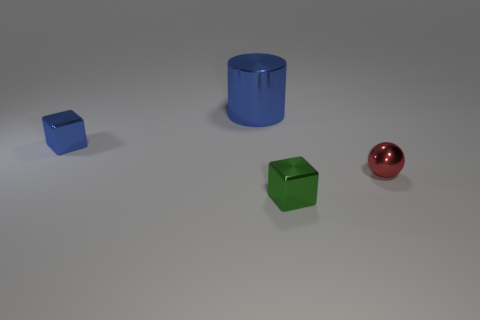Imagine this is a scene from a story. What narrative could you construct about these objects? In a narrative context, these objects could symbolize characters or elements within a tale of difference and unity. The small blue cube could represent the young, curious individual starting a journey. The green cube could depict a wise mentor with deeper layers, akin to the object's more complex shape. The red sphere might symbolize a guiding spirit or a beacon of wisdom, slightly apart but deeply connected to the rest. The cylindrical object, with its open top, could embody an unknown destination or goal for the other characters, its functional design a metaphor for potential and growth. 